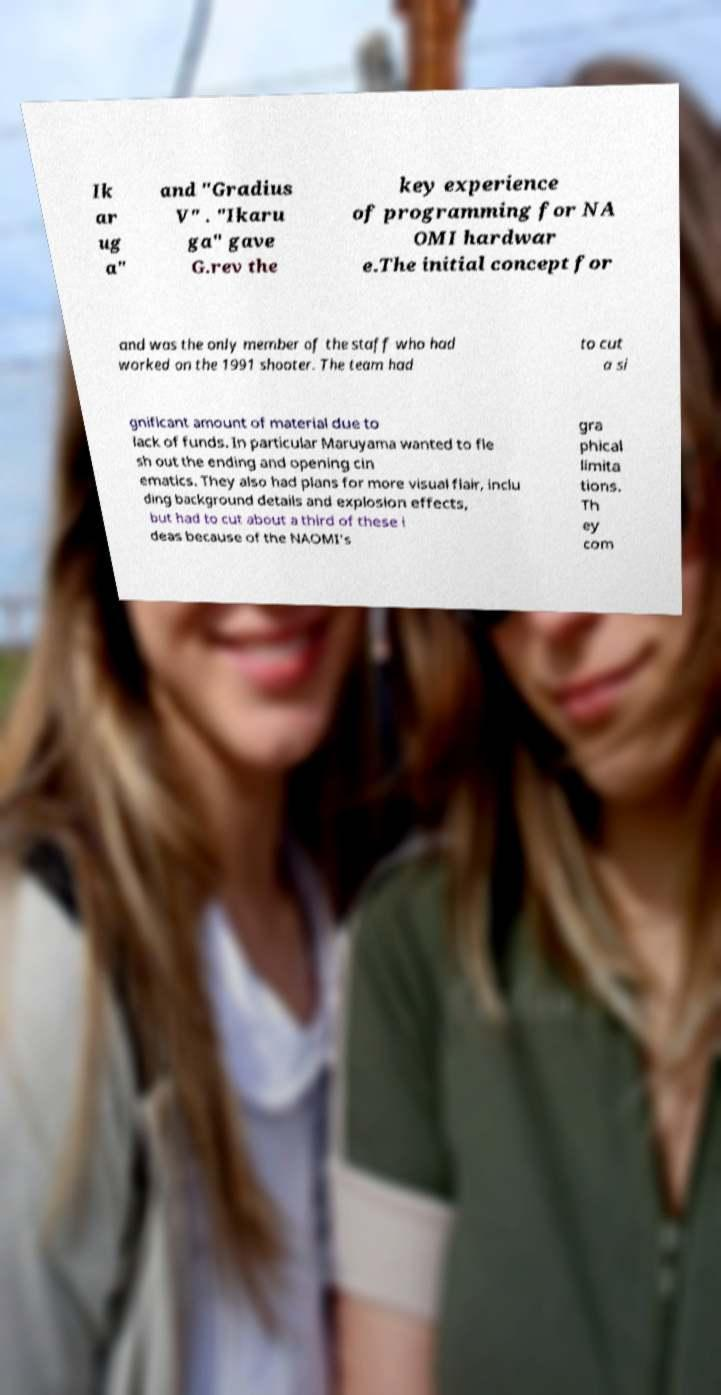Can you read and provide the text displayed in the image?This photo seems to have some interesting text. Can you extract and type it out for me? Ik ar ug a" and "Gradius V" . "Ikaru ga" gave G.rev the key experience of programming for NA OMI hardwar e.The initial concept for and was the only member of the staff who had worked on the 1991 shooter. The team had to cut a si gnificant amount of material due to lack of funds. In particular Maruyama wanted to fle sh out the ending and opening cin ematics. They also had plans for more visual flair, inclu ding background details and explosion effects, but had to cut about a third of these i deas because of the NAOMI's gra phical limita tions. Th ey com 